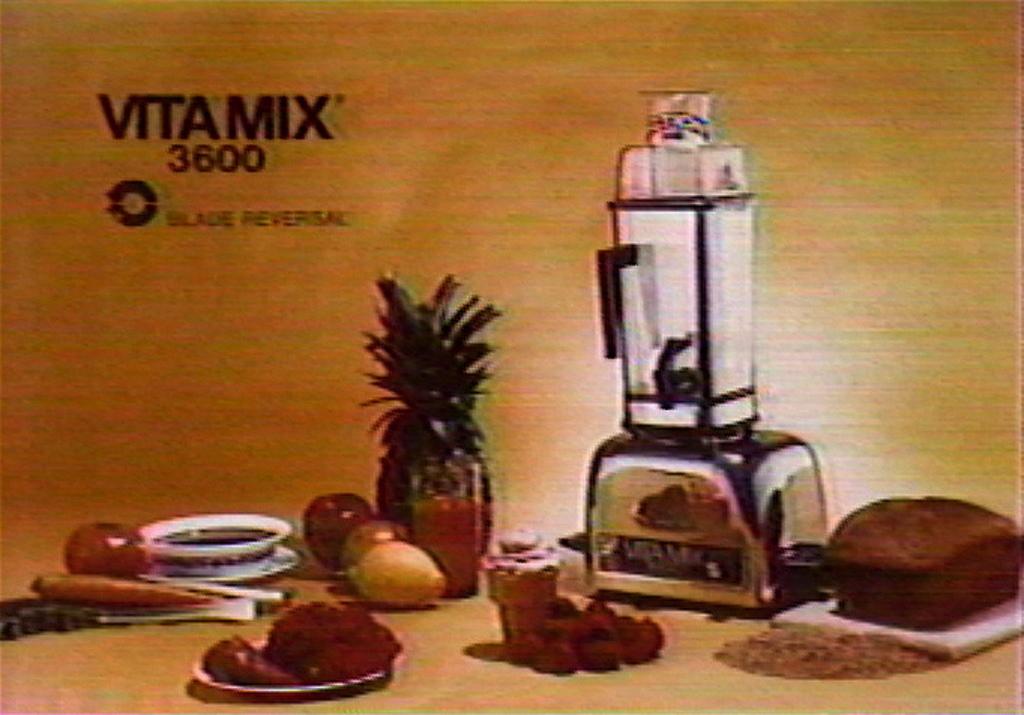What blade feature does this device offer?
Offer a very short reply. Blade reversal. What was the picture about?
Provide a succinct answer. Vitamix 3600. 